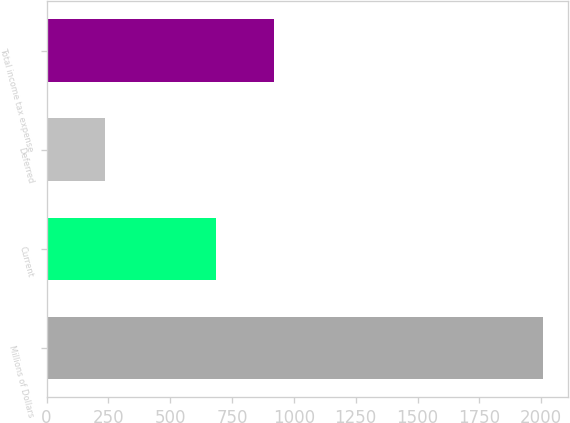<chart> <loc_0><loc_0><loc_500><loc_500><bar_chart><fcel>Millions of Dollars<fcel>Current<fcel>Deferred<fcel>Total income tax expense<nl><fcel>2006<fcel>684<fcel>235<fcel>919<nl></chart> 